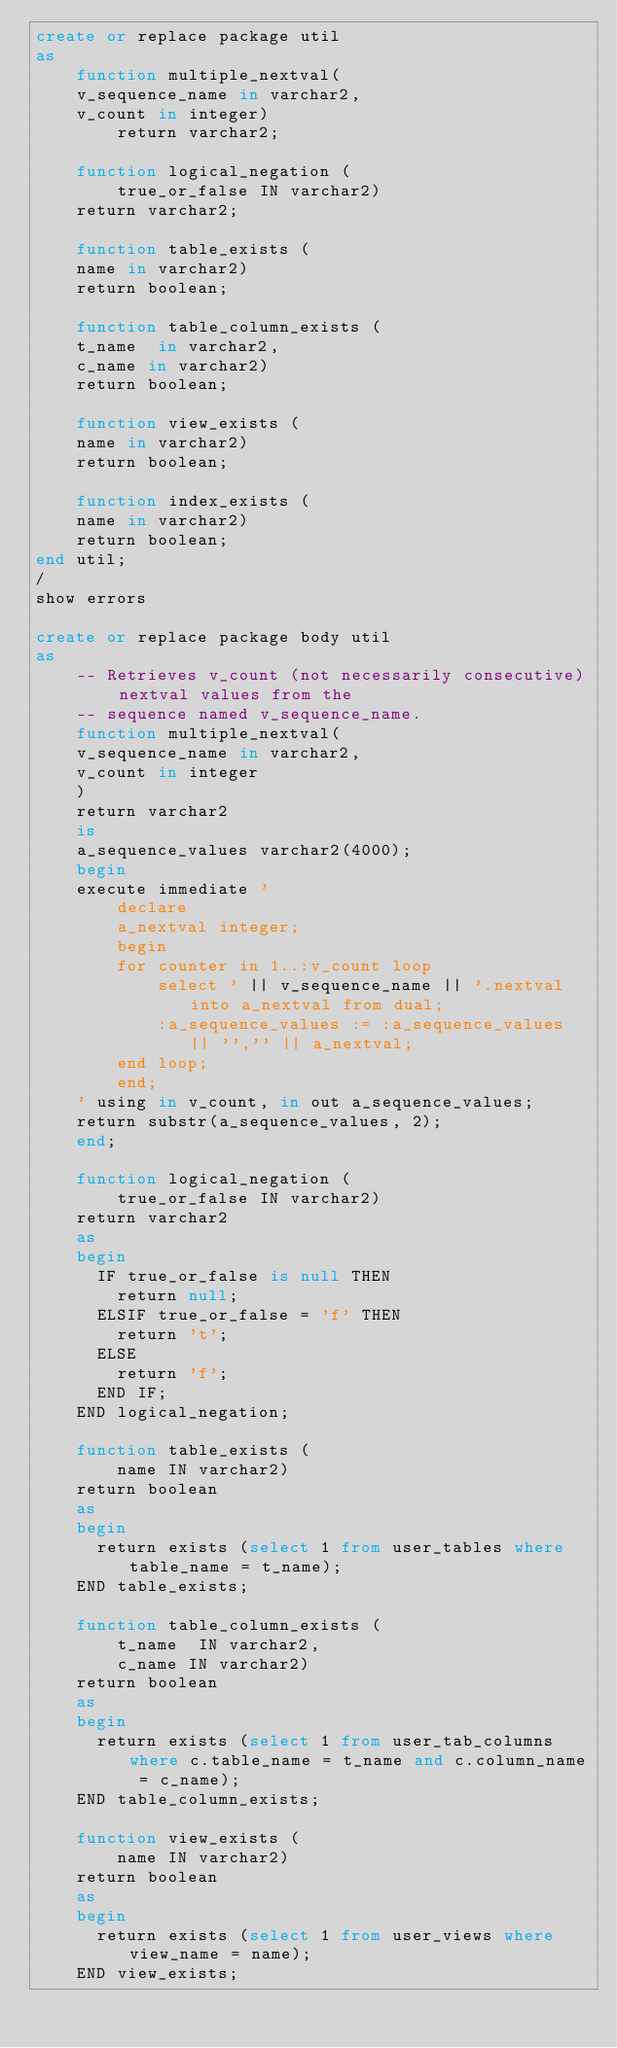Convert code to text. <code><loc_0><loc_0><loc_500><loc_500><_SQL_>create or replace package util
as
    function multiple_nextval(
	v_sequence_name in varchar2,
	v_count in integer)
        return varchar2;

    function logical_negation (
        true_or_false IN varchar2)
	return varchar2;
    
    function table_exists (
	name in varchar2)
	return boolean;
	
    function table_column_exists (
	t_name  in varchar2,
	c_name in varchar2)
	return boolean;
    
    function view_exists (
	name in varchar2)
	return boolean;
	
    function index_exists (
	name in varchar2)
	return boolean;
end util;
/
show errors

create or replace package body util
as
    -- Retrieves v_count (not necessarily consecutive) nextval values from the
    -- sequence named v_sequence_name.
    function multiple_nextval(
	v_sequence_name in varchar2,
	v_count in integer
    )
    return varchar2
    is
	a_sequence_values varchar2(4000);
    begin
	execute immediate '
	    declare
		a_nextval integer;
	    begin
		for counter in 1..:v_count loop
		    select ' || v_sequence_name || '.nextval into a_nextval from dual;
		    :a_sequence_values := :a_sequence_values || '','' || a_nextval;
		end loop;
	    end;
	' using in v_count, in out a_sequence_values;
	return substr(a_sequence_values, 2);
    end;

    function logical_negation (
        true_or_false IN varchar2)
    return varchar2
    as
    begin
      IF true_or_false is null THEN
        return null;
      ELSIF true_or_false = 'f' THEN
        return 't';   
      ELSE 
        return 'f';   
      END IF;
    END logical_negation;
    
    function table_exists (
        name IN varchar2)
    return boolean
    as
    begin
      return exists (select 1 from user_tables where table_name = t_name);
    END table_exists;
    
    function table_column_exists (
        t_name  IN varchar2,
        c_name IN varchar2)
    return boolean
    as
    begin
      return exists (select 1 from user_tab_columns where c.table_name = t_name and c.column_name = c_name);
    END table_column_exists;
    
    function view_exists (
        name IN varchar2)
    return boolean
    as
    begin
      return exists (select 1 from user_views where view_name = name);
    END view_exists;
    </code> 